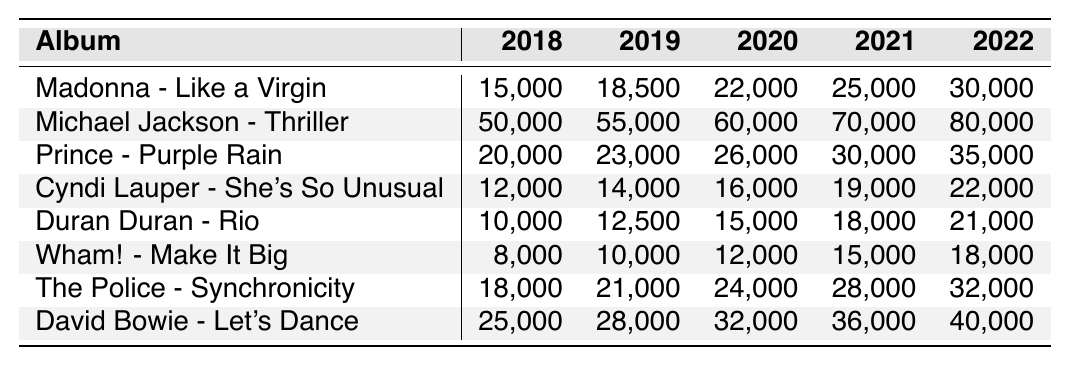What's the total vinyl sales for "Madonna - Like a Virgin" from 2018 to 2022? The sales for "Madonna - Like a Virgin" are 15,000 (2018) + 18,500 (2019) + 22,000 (2020) + 25,000 (2021) + 30,000 (2022). The total is 15,000 + 18,500 + 22,000 + 25,000 + 30,000 = 110,500.
Answer: 110,500 Which album had the highest sales in 2022? The sales for each album in 2022 are as follows: "Madonna - Like a Virgin" 30,000, "Michael Jackson - Thriller" 80,000, "Prince - Purple Rain" 35,000, "Cyndi Lauper - She's So Unusual" 22,000, "Duran Duran - Rio" 21,000, "Wham! - Make It Big" 18,000, "The Police - Synchronicity" 32,000, "David Bowie - Let's Dance" 40,000. Comparing these values, "Michael Jackson - Thriller" has the highest sales with 80,000.
Answer: Michael Jackson - Thriller What is the average vinyl sales of "Duran Duran - Rio" from 2018 to 2022? The sales for "Duran Duran - Rio" over the years are 10,000, 12,500, 15,000, 18,000, and 21,000. To find the average, sum these values: 10,000 + 12,500 + 15,000 + 18,000 + 21,000 = 76,500. Then divide by 5 (the number of years) to get the average: 76,500 / 5 = 15,300.
Answer: 15,300 Did "Cyndi Lauper - She's So Unusual" have higher sales in 2021 than in 2020? The sales for "Cyndi Lauper - She's So Unusual" in 2020 were 16,000, and in 2021 they were 19,000. Since 19,000 (2021) is greater than 16,000 (2020), the statement is true.
Answer: Yes How many more albums sold over 20,000 copies in 2022 compared to 2018? In 2018, the albums that sold over 20,000 were "Michael Jackson - Thriller" (50,000), "Prince - Purple Rain" (20,000), "The Police - Synchronicity" (18,000), and "David Bowie - Let's Dance" (25,000). The only album that exceeds 20,000 in 2018 is "Michael Jackson - Thriller." In 2022, the albums over 20,000 were "Michael Jackson - Thriller" (80,000), "Prince - Purple Rain" (35,000), "The Police - Synchronicity" (32,000), and "David Bowie - Let's Dance" (40,000). So, there are 4 albums (2022) and only 1 (2018), resulting in an increase of 4 - 1 = 3 more albums.
Answer: 3 What are the total sales for "The Police - Synchronicity" across all years? The sales for "The Police - Synchronicity" are 18,000 for 2018, 21,000 for 2019, 24,000 for 2020, 28,000 for 2021, and 32,000 for 2022. Summing these gives: 18,000 + 21,000 + 24,000 + 28,000 + 32,000 = 123,000.
Answer: 123,000 